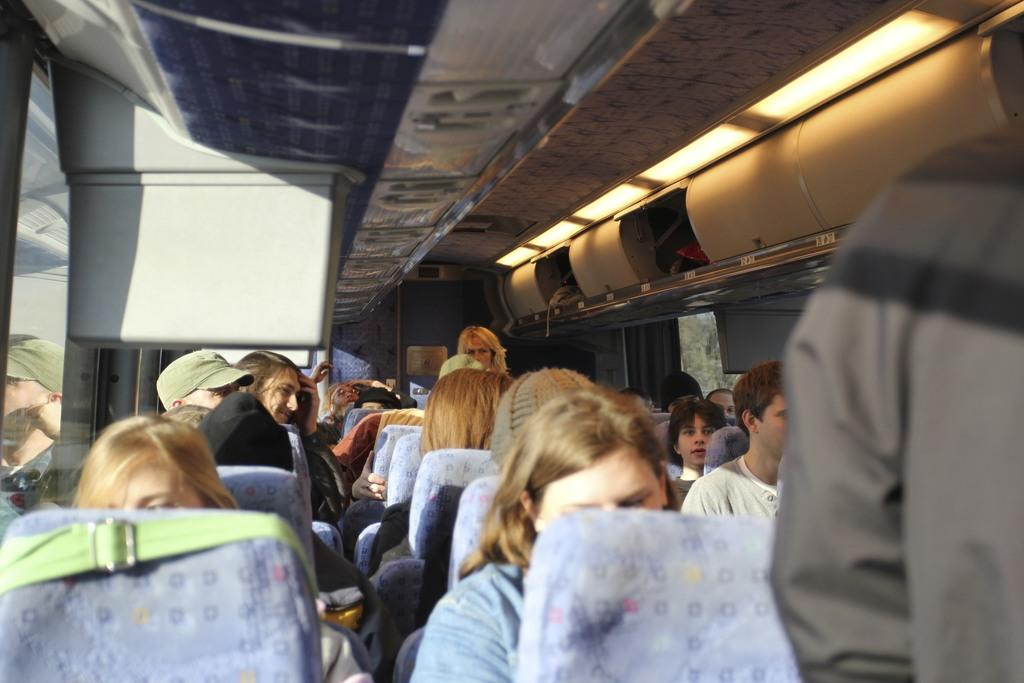What are the people in the image doing? The people in the image are sitting in a vehicle. What feature allows the people to see outside the vehicle? There are windows on either side of the vehicle. What can be used to illuminate the area around the vehicle? There are lights at the top of the vehicle. What type of dress is the smoke wearing in the image? There is no smoke or dress present in the image. Can you tell me how many spades are visible in the image? There are no spades present in the image. 